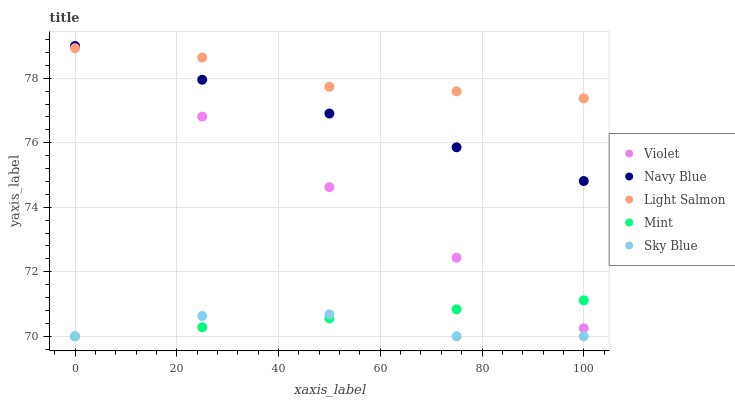Does Sky Blue have the minimum area under the curve?
Answer yes or no. Yes. Does Light Salmon have the maximum area under the curve?
Answer yes or no. Yes. Does Navy Blue have the minimum area under the curve?
Answer yes or no. No. Does Navy Blue have the maximum area under the curve?
Answer yes or no. No. Is Navy Blue the smoothest?
Answer yes or no. Yes. Is Sky Blue the roughest?
Answer yes or no. Yes. Is Light Salmon the smoothest?
Answer yes or no. No. Is Light Salmon the roughest?
Answer yes or no. No. Does Sky Blue have the lowest value?
Answer yes or no. Yes. Does Navy Blue have the lowest value?
Answer yes or no. No. Does Violet have the highest value?
Answer yes or no. Yes. Does Light Salmon have the highest value?
Answer yes or no. No. Is Mint less than Light Salmon?
Answer yes or no. Yes. Is Violet greater than Sky Blue?
Answer yes or no. Yes. Does Light Salmon intersect Violet?
Answer yes or no. Yes. Is Light Salmon less than Violet?
Answer yes or no. No. Is Light Salmon greater than Violet?
Answer yes or no. No. Does Mint intersect Light Salmon?
Answer yes or no. No. 